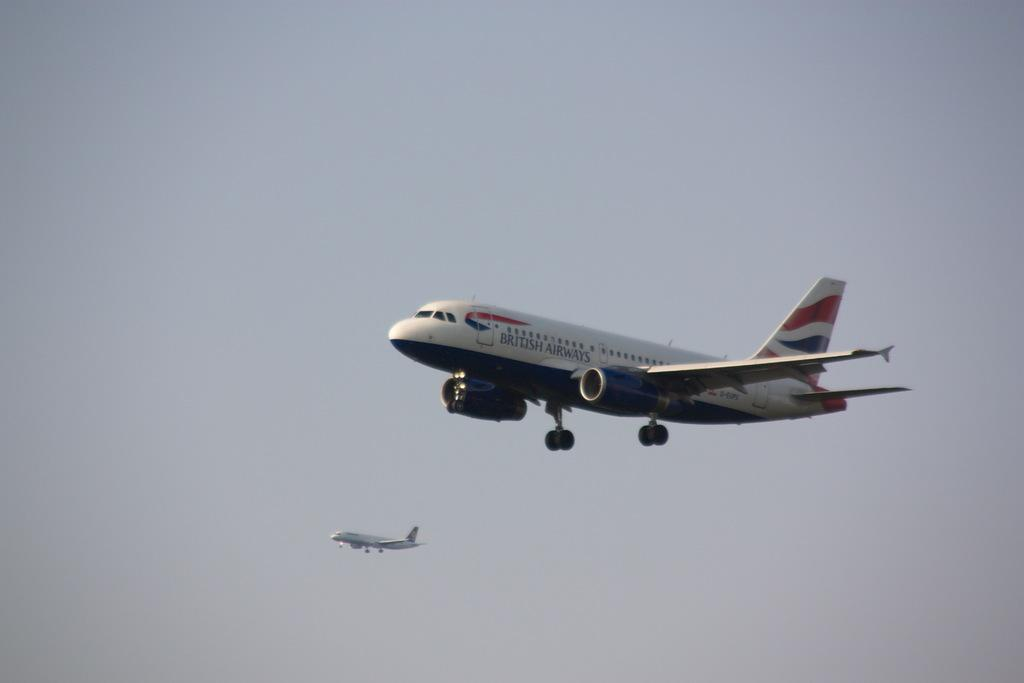Where was the picture taken? The picture was clicked outside. What can be seen in the sky in the image? There are two airplanes flying in the sky. What is visible in the background of the image? The sky is visible in the background of the image. How many goldfish can be seen swimming in the sky in the image? There are no goldfish present in the image; it features two airplanes flying in the sky. What type of jellyfish can be seen floating in the background of the image? There are no jellyfish present in the image; the background features the sky. 